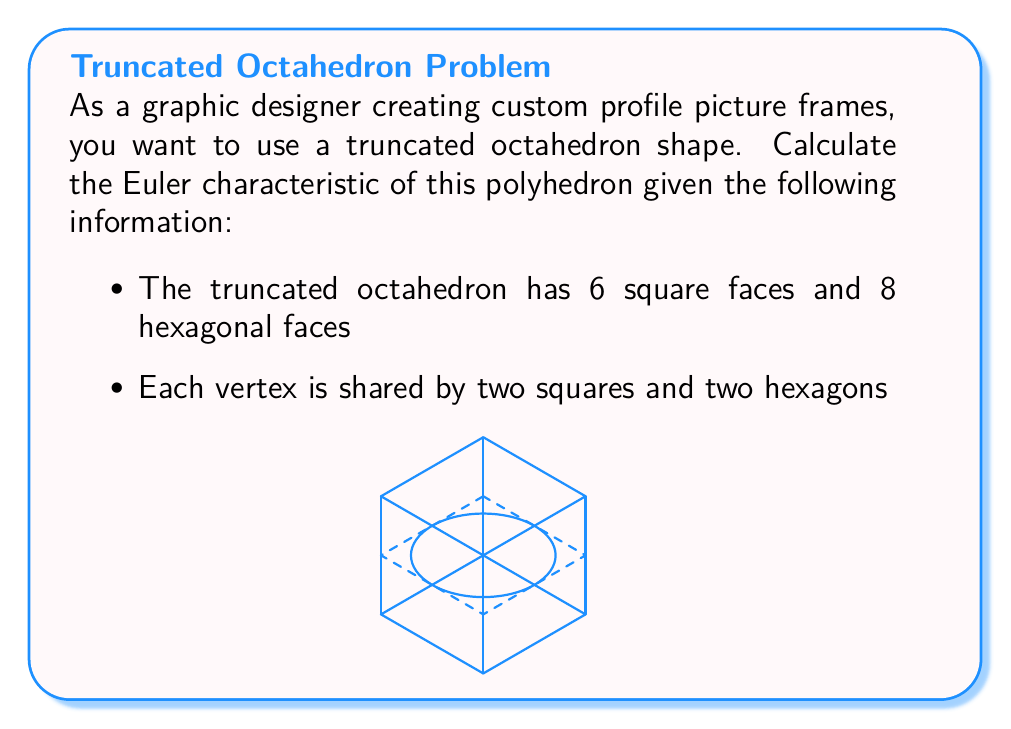What is the answer to this math problem? To determine the Euler characteristic of the truncated octahedron, we need to use the formula:

$$\chi = V - E + F$$

Where:
$\chi$ = Euler characteristic
$V$ = Number of vertices
$E$ = Number of edges
$F$ = Number of faces

Let's find each component:

1. Number of faces (F):
   We're given that there are 6 square faces and 8 hexagonal faces.
   $F = 6 + 8 = 14$

2. Number of vertices (V):
   Each vertex is shared by two squares and two hexagons.
   Total number of vertex-face connections = $(4 \times 6) + (6 \times 8) = 24 + 48 = 72$
   Since each vertex connects to 4 faces, $V = 72 \div 4 = 18$

3. Number of edges (E):
   We can use the fact that each edge is shared by exactly two faces.
   Total number of face-edge connections = $(4 \times 6) + (6 \times 8) = 24 + 48 = 72$
   Since each edge is counted twice, $E = 72 \div 2 = 36$

Now we can calculate the Euler characteristic:

$$\chi = V - E + F = 18 - 36 + 14 = -4$$

To verify, we can use the fact that for any convex polyhedron, $\chi = 2$. The truncated octahedron is indeed a convex polyhedron, so our calculation is correct.
Answer: $\chi = 2$ 